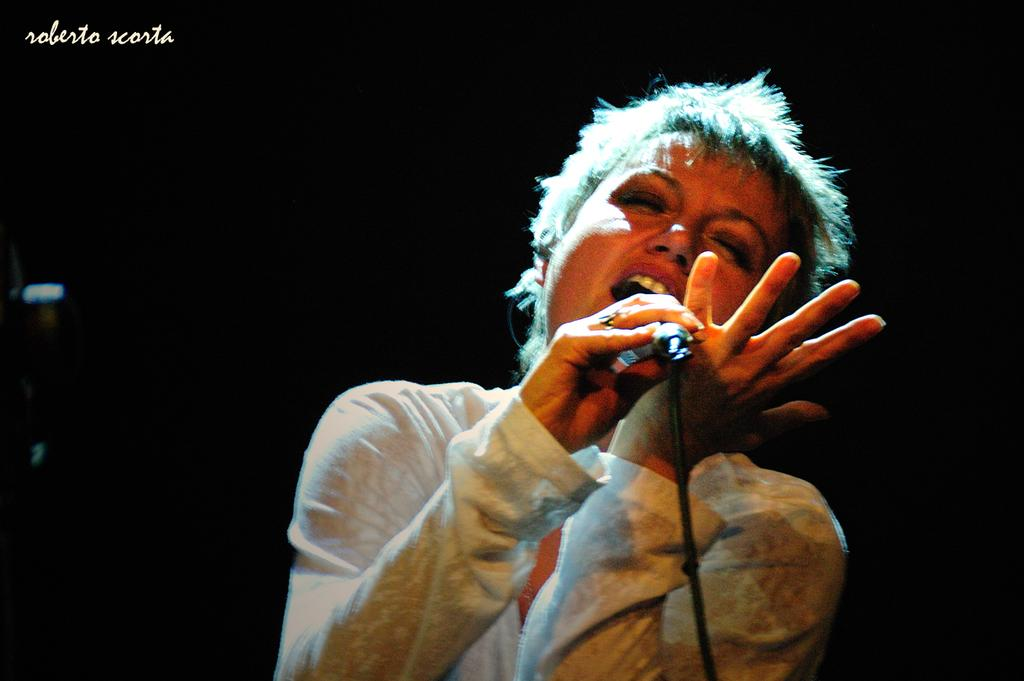What is the main subject of the image? There is a lady in the image. What is the lady doing in the image? The lady is singing. What object is the lady holding in the image? The lady is holding a microphone. What can be seen at the top of the image? There is text at the top of the image. What color is the background of the image? The background of the image is black in color. What type of spot can be seen on the lady's dress in the image? There is no spot visible on the lady's dress in the image. What time of day is it in the image? The time of day cannot be determined from the image, as there are no clues to suggest whether it is morning, afternoon, or evening. 